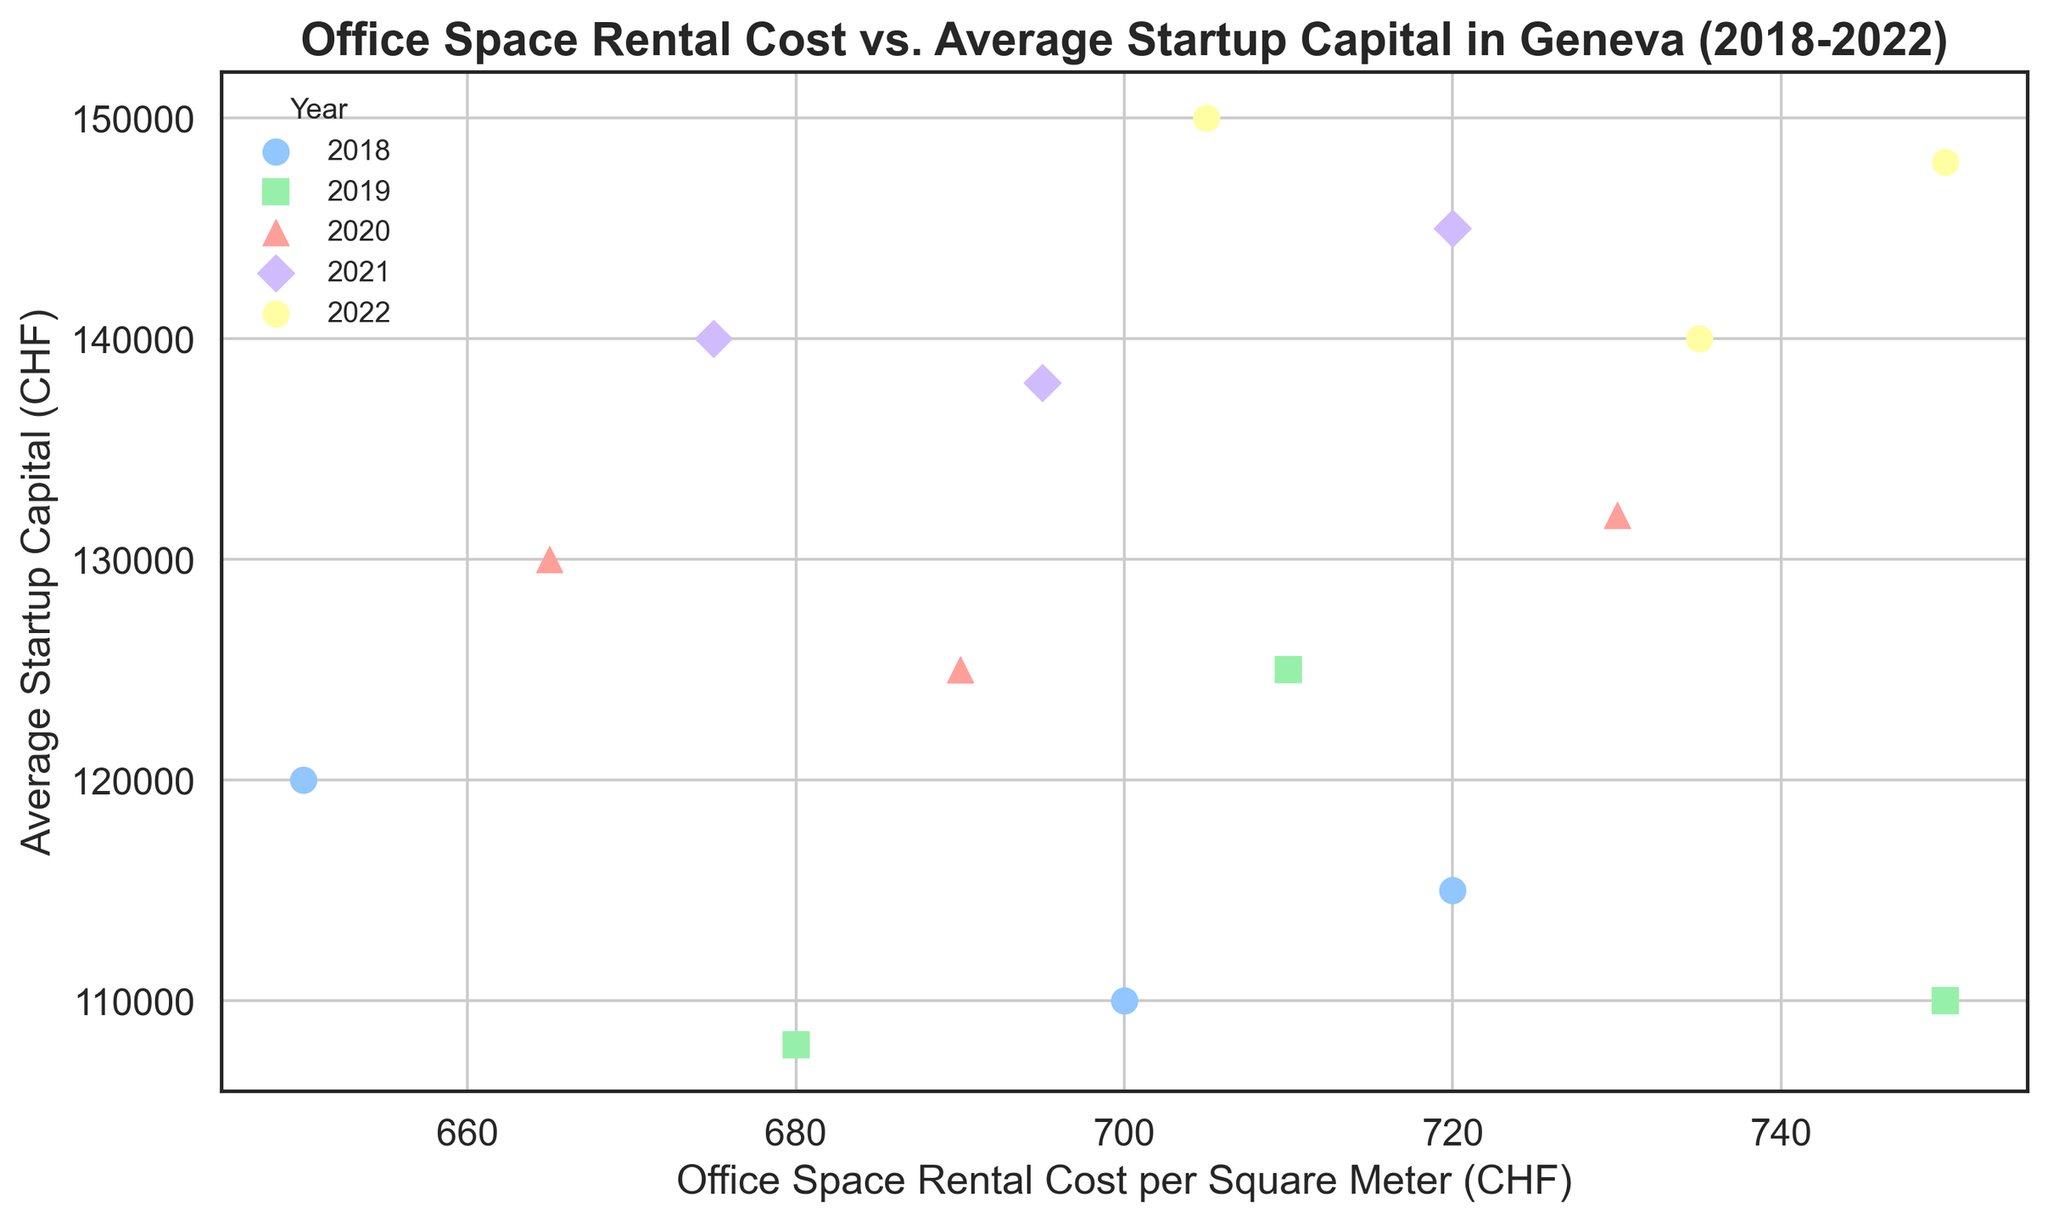What's the trend in office space rental costs from 2018 to 2022? To determine the trend, look at how the rental costs per square meter (CHF) change across the years 2018 to 2022. From the plot, observe that the rental costs generally increase over the years from 2018 to 2022.
Answer: Increasing trend Which year had the highest average startup capital in the dataset? Identify the highest cluster of points along the "Average Startup Capital (CHF)" axis and see which year it belongs to. The highest value of average startup capital appears in the year 2022.
Answer: 2022 Is there a correlation between office space rental cost and average startup capital? To determine if there's a correlation, observe the general direction of the points in the scatter plot. The plot shows a positive correlation as higher rental costs are generally associated with higher startup capital.
Answer: Positive correlation Which year has the widest range of office space rental costs? By looking at the spread of data points for each year on the x-axis (Office Space Rental Cost per Square Meter (CHF)), note the range of values. The year 2019 appears to have the widest range because it spans from around 680 to 750 CHF.
Answer: 2019 Between 2020 and 2021, did the average startup capital increase or decrease? Compare the clusters of points for 2020 and 2021 along the y-axis (Average Startup Capital (CHF)). The plot shows that in 2021, the points are generally higher compared to 2020, indicating an increase.
Answer: Increase What is the minimum office space rental cost recorded in the dataset and in which year? Identify the lowest point along the x-axis and check the corresponding year. The minimum rental cost recorded is 650 CHF in the year 2018.
Answer: 650 CHF in 2018 Considering 2018, what is the range in average startup capital? Refer to the data points for 2018 and arrange their y-values to identify the minimum and maximum values. The range is from 110,000 CHF to 120,000 CHF.
Answer: 10,000 CHF Does any year show a tighter clustering of points on the plot? Look for the year where the points are closely grouped without much spread on both axes. The year 2022 shows a tighter clustering of points, indicating lower variability.
Answer: 2022 If you were to start a business, in which year would you find the lowest average rental cost? Consider the year with the cluster of points closest to the lower values of the x-axis. The year 2018 has the lowest average rental costs.
Answer: 2018 